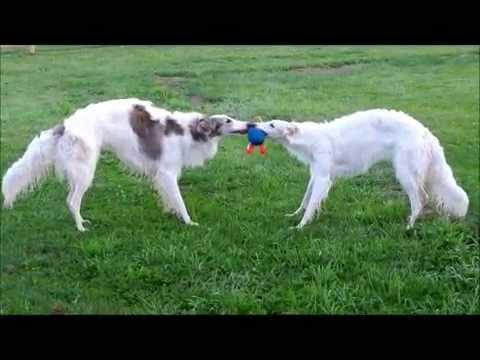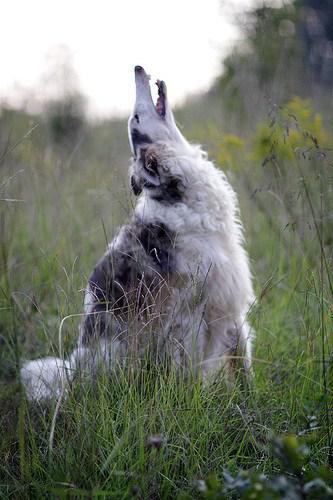The first image is the image on the left, the second image is the image on the right. Considering the images on both sides, is "There are more than two dogs." valid? Answer yes or no. Yes. The first image is the image on the left, the second image is the image on the right. Given the left and right images, does the statement "There are no more than two dogs." hold true? Answer yes or no. No. 